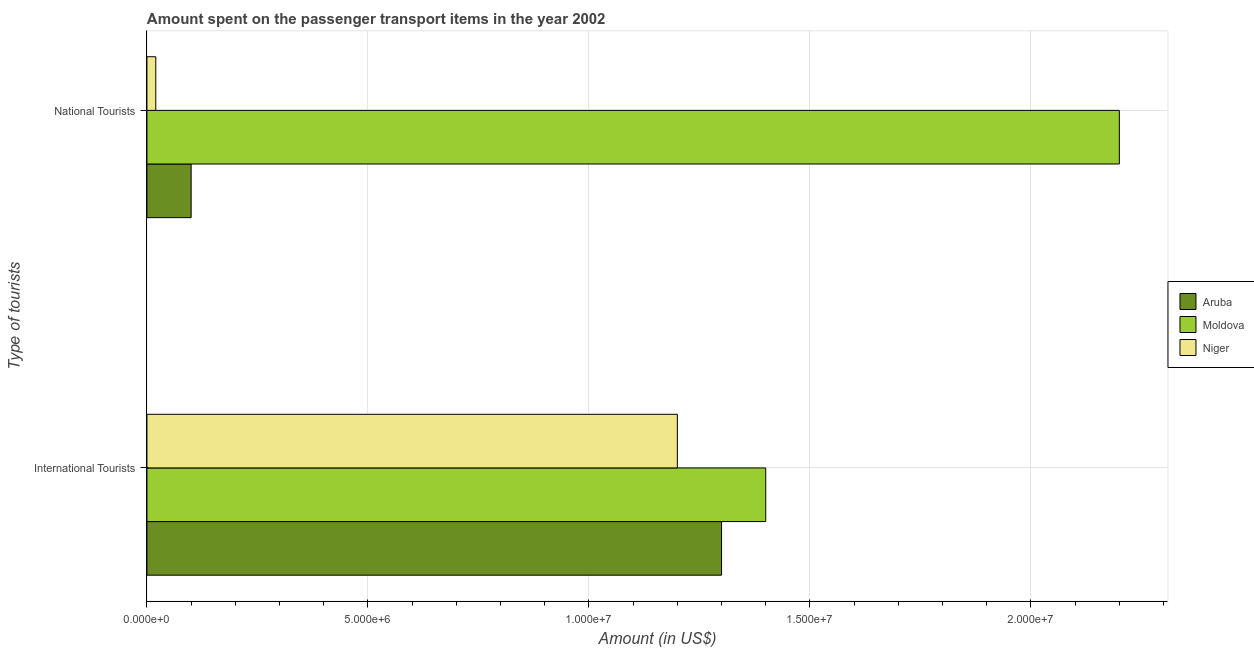How many groups of bars are there?
Your answer should be very brief. 2. Are the number of bars per tick equal to the number of legend labels?
Offer a terse response. Yes. How many bars are there on the 1st tick from the bottom?
Provide a succinct answer. 3. What is the label of the 2nd group of bars from the top?
Provide a succinct answer. International Tourists. What is the amount spent on transport items of international tourists in Moldova?
Offer a terse response. 1.40e+07. Across all countries, what is the maximum amount spent on transport items of national tourists?
Your response must be concise. 2.20e+07. Across all countries, what is the minimum amount spent on transport items of national tourists?
Ensure brevity in your answer.  2.00e+05. In which country was the amount spent on transport items of international tourists maximum?
Ensure brevity in your answer.  Moldova. In which country was the amount spent on transport items of international tourists minimum?
Provide a succinct answer. Niger. What is the total amount spent on transport items of national tourists in the graph?
Make the answer very short. 2.32e+07. What is the difference between the amount spent on transport items of international tourists in Moldova and that in Niger?
Make the answer very short. 2.00e+06. What is the difference between the amount spent on transport items of national tourists in Aruba and the amount spent on transport items of international tourists in Niger?
Your response must be concise. -1.10e+07. What is the average amount spent on transport items of national tourists per country?
Your answer should be compact. 7.73e+06. What is the difference between the amount spent on transport items of national tourists and amount spent on transport items of international tourists in Niger?
Your response must be concise. -1.18e+07. What is the ratio of the amount spent on transport items of international tourists in Moldova to that in Niger?
Your response must be concise. 1.17. In how many countries, is the amount spent on transport items of national tourists greater than the average amount spent on transport items of national tourists taken over all countries?
Provide a succinct answer. 1. What does the 2nd bar from the top in International Tourists represents?
Your answer should be compact. Moldova. What does the 2nd bar from the bottom in National Tourists represents?
Offer a terse response. Moldova. Are all the bars in the graph horizontal?
Your response must be concise. Yes. How many countries are there in the graph?
Provide a short and direct response. 3. What is the difference between two consecutive major ticks on the X-axis?
Keep it short and to the point. 5.00e+06. Are the values on the major ticks of X-axis written in scientific E-notation?
Your response must be concise. Yes. Does the graph contain grids?
Provide a succinct answer. Yes. How many legend labels are there?
Offer a terse response. 3. What is the title of the graph?
Give a very brief answer. Amount spent on the passenger transport items in the year 2002. What is the label or title of the X-axis?
Your answer should be very brief. Amount (in US$). What is the label or title of the Y-axis?
Ensure brevity in your answer.  Type of tourists. What is the Amount (in US$) of Aruba in International Tourists?
Keep it short and to the point. 1.30e+07. What is the Amount (in US$) of Moldova in International Tourists?
Give a very brief answer. 1.40e+07. What is the Amount (in US$) in Niger in International Tourists?
Offer a very short reply. 1.20e+07. What is the Amount (in US$) of Moldova in National Tourists?
Make the answer very short. 2.20e+07. What is the Amount (in US$) in Niger in National Tourists?
Your response must be concise. 2.00e+05. Across all Type of tourists, what is the maximum Amount (in US$) of Aruba?
Keep it short and to the point. 1.30e+07. Across all Type of tourists, what is the maximum Amount (in US$) in Moldova?
Ensure brevity in your answer.  2.20e+07. Across all Type of tourists, what is the minimum Amount (in US$) in Aruba?
Provide a succinct answer. 1.00e+06. Across all Type of tourists, what is the minimum Amount (in US$) in Moldova?
Offer a terse response. 1.40e+07. What is the total Amount (in US$) of Aruba in the graph?
Your answer should be very brief. 1.40e+07. What is the total Amount (in US$) of Moldova in the graph?
Provide a succinct answer. 3.60e+07. What is the total Amount (in US$) of Niger in the graph?
Your answer should be compact. 1.22e+07. What is the difference between the Amount (in US$) in Aruba in International Tourists and that in National Tourists?
Offer a very short reply. 1.20e+07. What is the difference between the Amount (in US$) in Moldova in International Tourists and that in National Tourists?
Your answer should be very brief. -8.00e+06. What is the difference between the Amount (in US$) of Niger in International Tourists and that in National Tourists?
Your answer should be very brief. 1.18e+07. What is the difference between the Amount (in US$) in Aruba in International Tourists and the Amount (in US$) in Moldova in National Tourists?
Offer a terse response. -9.00e+06. What is the difference between the Amount (in US$) in Aruba in International Tourists and the Amount (in US$) in Niger in National Tourists?
Provide a short and direct response. 1.28e+07. What is the difference between the Amount (in US$) of Moldova in International Tourists and the Amount (in US$) of Niger in National Tourists?
Your response must be concise. 1.38e+07. What is the average Amount (in US$) of Aruba per Type of tourists?
Offer a very short reply. 7.00e+06. What is the average Amount (in US$) in Moldova per Type of tourists?
Ensure brevity in your answer.  1.80e+07. What is the average Amount (in US$) in Niger per Type of tourists?
Your answer should be compact. 6.10e+06. What is the difference between the Amount (in US$) in Moldova and Amount (in US$) in Niger in International Tourists?
Provide a succinct answer. 2.00e+06. What is the difference between the Amount (in US$) of Aruba and Amount (in US$) of Moldova in National Tourists?
Ensure brevity in your answer.  -2.10e+07. What is the difference between the Amount (in US$) in Moldova and Amount (in US$) in Niger in National Tourists?
Your answer should be compact. 2.18e+07. What is the ratio of the Amount (in US$) of Aruba in International Tourists to that in National Tourists?
Keep it short and to the point. 13. What is the ratio of the Amount (in US$) of Moldova in International Tourists to that in National Tourists?
Your response must be concise. 0.64. What is the difference between the highest and the second highest Amount (in US$) of Aruba?
Offer a very short reply. 1.20e+07. What is the difference between the highest and the second highest Amount (in US$) in Moldova?
Give a very brief answer. 8.00e+06. What is the difference between the highest and the second highest Amount (in US$) of Niger?
Offer a very short reply. 1.18e+07. What is the difference between the highest and the lowest Amount (in US$) of Niger?
Ensure brevity in your answer.  1.18e+07. 